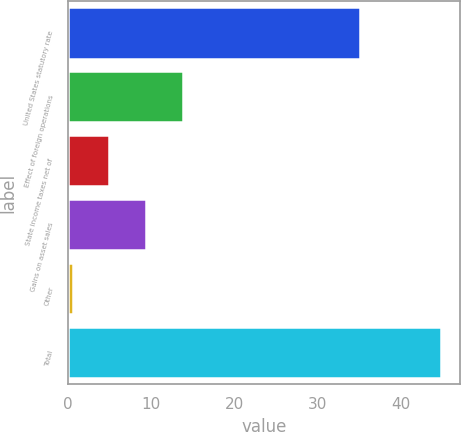Convert chart to OTSL. <chart><loc_0><loc_0><loc_500><loc_500><bar_chart><fcel>United States statutory rate<fcel>Effect of foreign operations<fcel>State income taxes net of<fcel>Gains on asset sales<fcel>Other<fcel>Total<nl><fcel>35<fcel>13.86<fcel>5.02<fcel>9.44<fcel>0.6<fcel>44.8<nl></chart> 